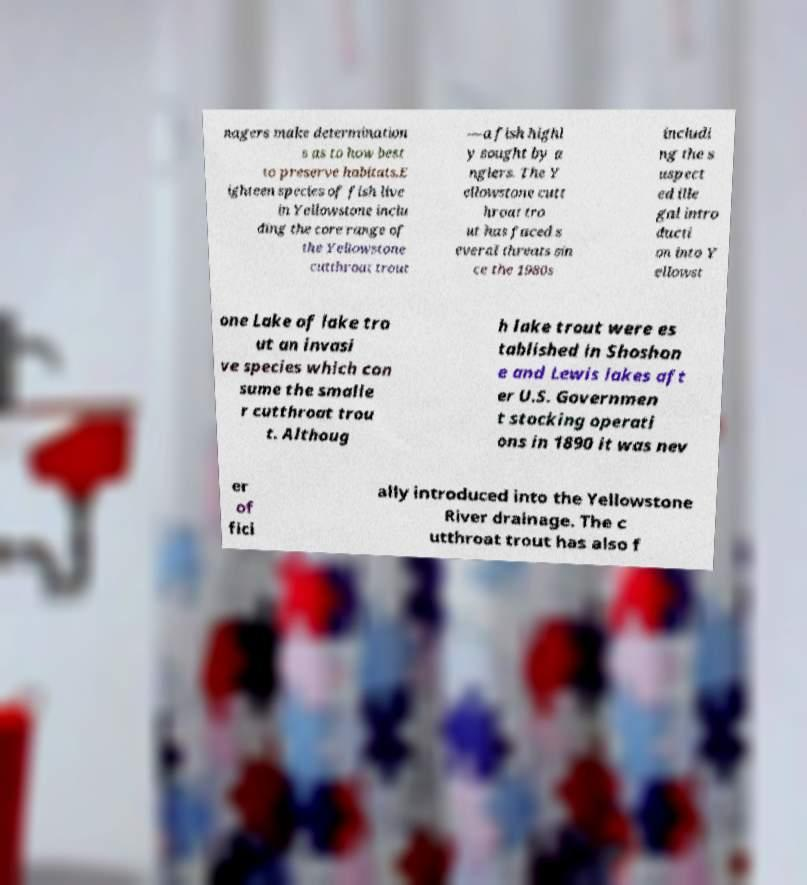What messages or text are displayed in this image? I need them in a readable, typed format. nagers make determination s as to how best to preserve habitats.E ighteen species of fish live in Yellowstone inclu ding the core range of the Yellowstone cutthroat trout —a fish highl y sought by a nglers. The Y ellowstone cutt hroat tro ut has faced s everal threats sin ce the 1980s includi ng the s uspect ed ille gal intro ducti on into Y ellowst one Lake of lake tro ut an invasi ve species which con sume the smalle r cutthroat trou t. Althoug h lake trout were es tablished in Shoshon e and Lewis lakes aft er U.S. Governmen t stocking operati ons in 1890 it was nev er of fici ally introduced into the Yellowstone River drainage. The c utthroat trout has also f 